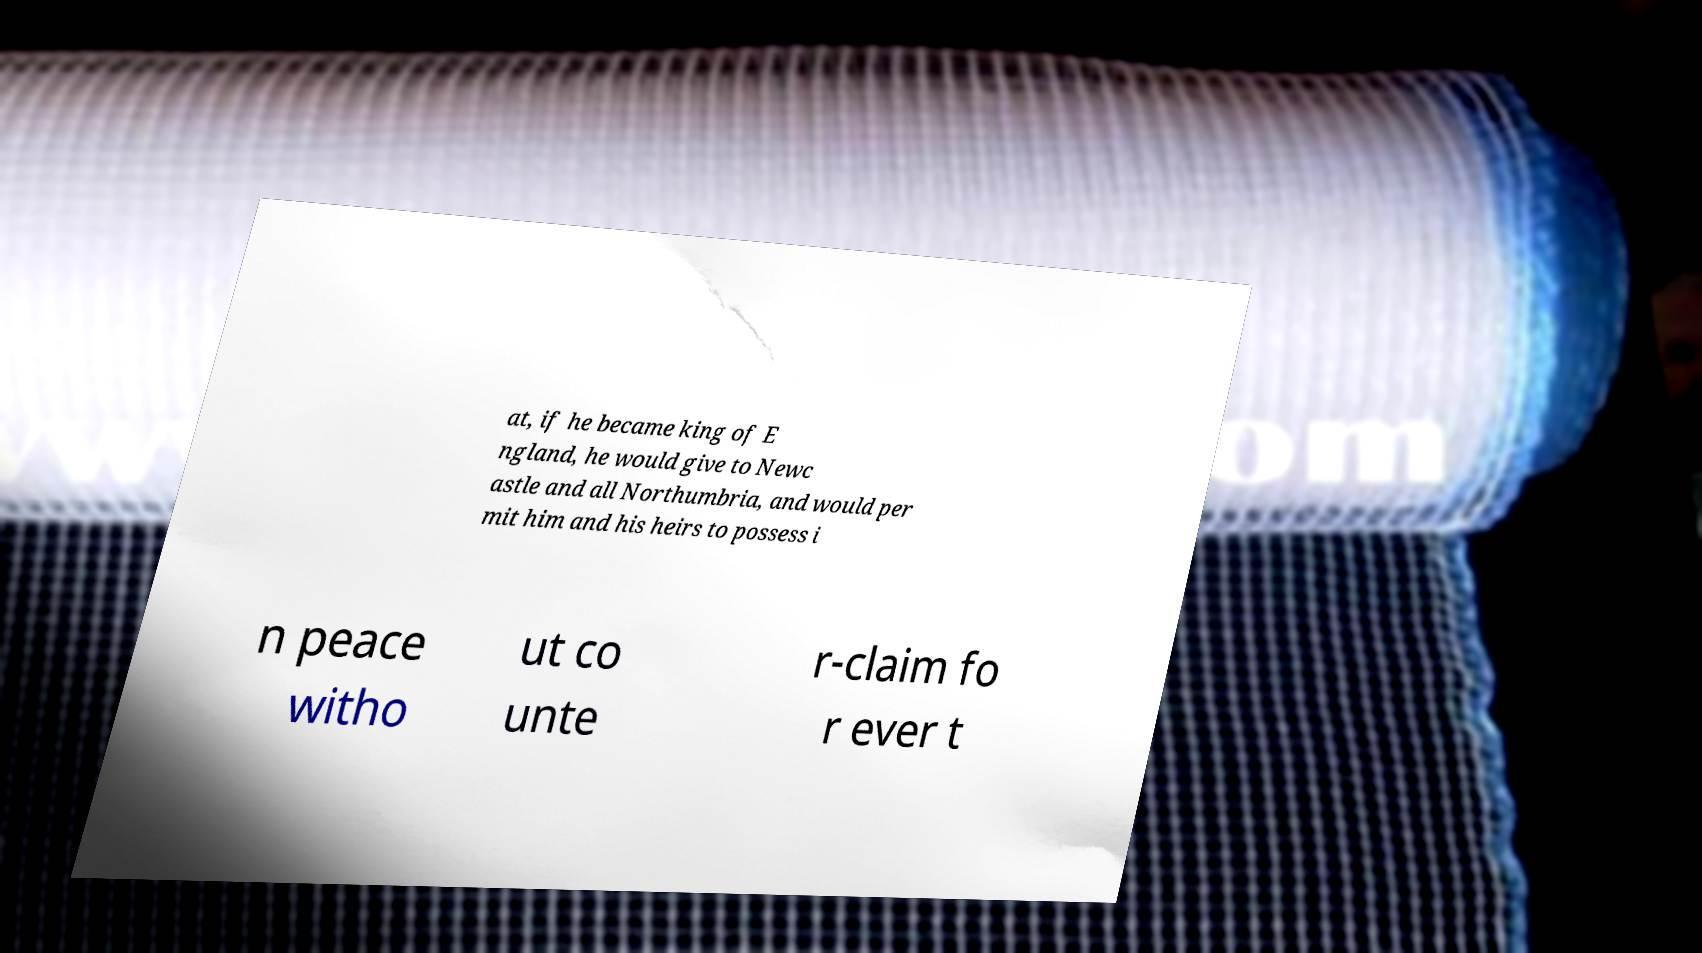What messages or text are displayed in this image? I need them in a readable, typed format. at, if he became king of E ngland, he would give to Newc astle and all Northumbria, and would per mit him and his heirs to possess i n peace witho ut co unte r-claim fo r ever t 